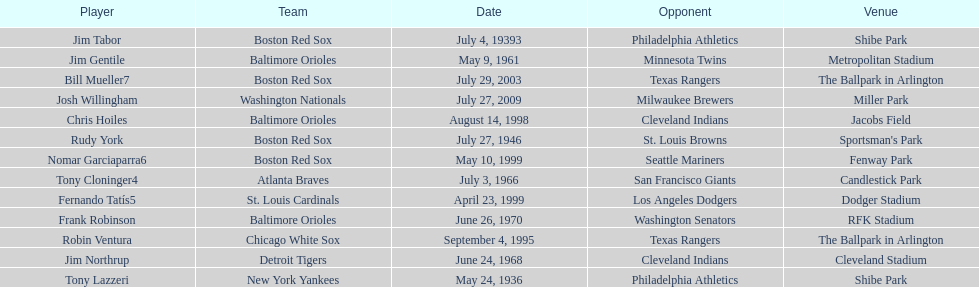What is the number of times a boston red sox player has had two grand slams in one game? 4. 